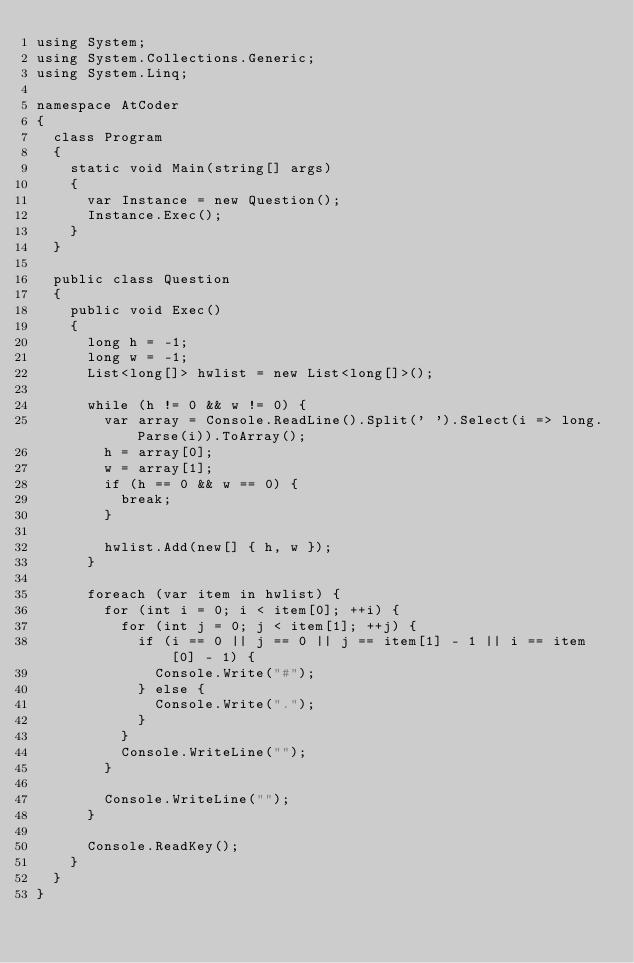<code> <loc_0><loc_0><loc_500><loc_500><_C#_>using System;
using System.Collections.Generic;
using System.Linq;

namespace AtCoder
{
	class Program
	{
		static void Main(string[] args)
		{
			var Instance = new Question();
			Instance.Exec();
		}
	}

	public class Question
	{
		public void Exec()
		{
			long h = -1;
			long w = -1;
			List<long[]> hwlist = new List<long[]>();

			while (h != 0 && w != 0) {
				var array = Console.ReadLine().Split(' ').Select(i => long.Parse(i)).ToArray();
				h = array[0];
				w = array[1];
				if (h == 0 && w == 0) {
					break;
				}

				hwlist.Add(new[] { h, w });
			}

			foreach (var item in hwlist) {
				for (int i = 0; i < item[0]; ++i) {
					for (int j = 0; j < item[1]; ++j) {
						if (i == 0 || j == 0 || j == item[1] - 1 || i == item[0] - 1) {
							Console.Write("#");
						} else {
							Console.Write(".");
						}
					}
					Console.WriteLine("");
				}

				Console.WriteLine("");
			}

			Console.ReadKey();
		}
	}
}
</code> 